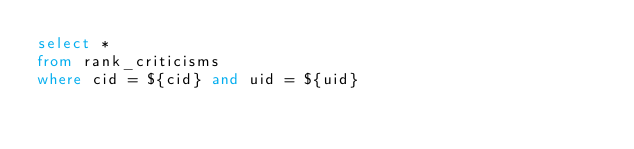Convert code to text. <code><loc_0><loc_0><loc_500><loc_500><_SQL_>select *
from rank_criticisms
where cid = ${cid} and uid = ${uid}</code> 